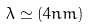Convert formula to latex. <formula><loc_0><loc_0><loc_500><loc_500>\lambda \simeq ( 4 n m ) \,</formula> 